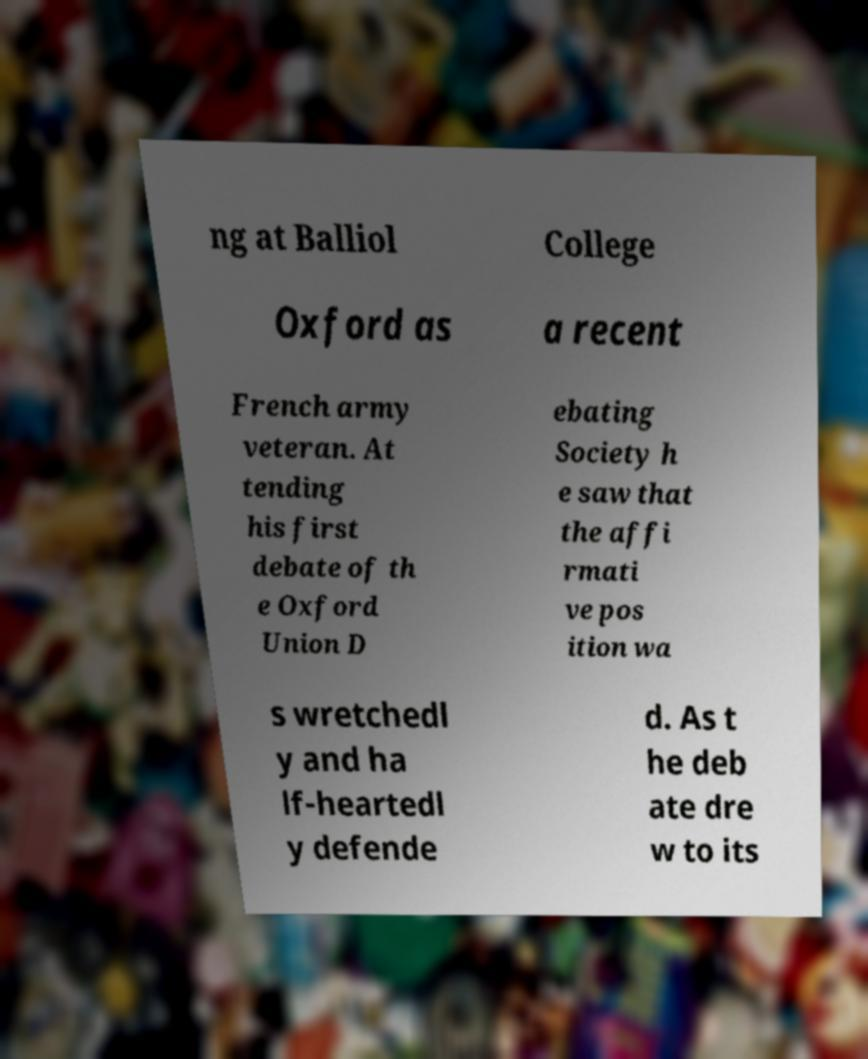Please read and relay the text visible in this image. What does it say? ng at Balliol College Oxford as a recent French army veteran. At tending his first debate of th e Oxford Union D ebating Society h e saw that the affi rmati ve pos ition wa s wretchedl y and ha lf-heartedl y defende d. As t he deb ate dre w to its 